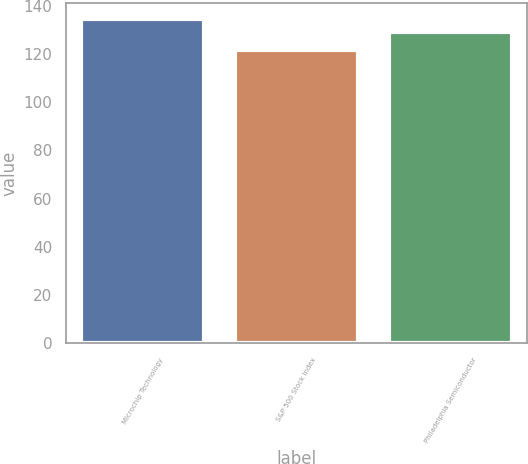Convert chart. <chart><loc_0><loc_0><loc_500><loc_500><bar_chart><fcel>Microchip Technology<fcel>S&P 500 Stock Index<fcel>Philadelphia Semiconductor<nl><fcel>134.48<fcel>121.86<fcel>129.22<nl></chart> 